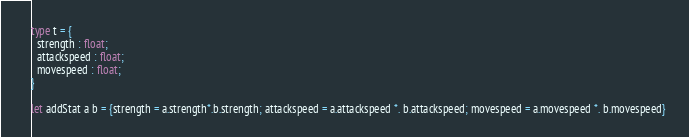<code> <loc_0><loc_0><loc_500><loc_500><_OCaml_>type t = {
  strength : float;
  attackspeed : float;
  movespeed : float;
}

let addStat a b = {strength = a.strength*.b.strength; attackspeed = a.attackspeed *. b.attackspeed; movespeed = a.movespeed *. b.movespeed}</code> 